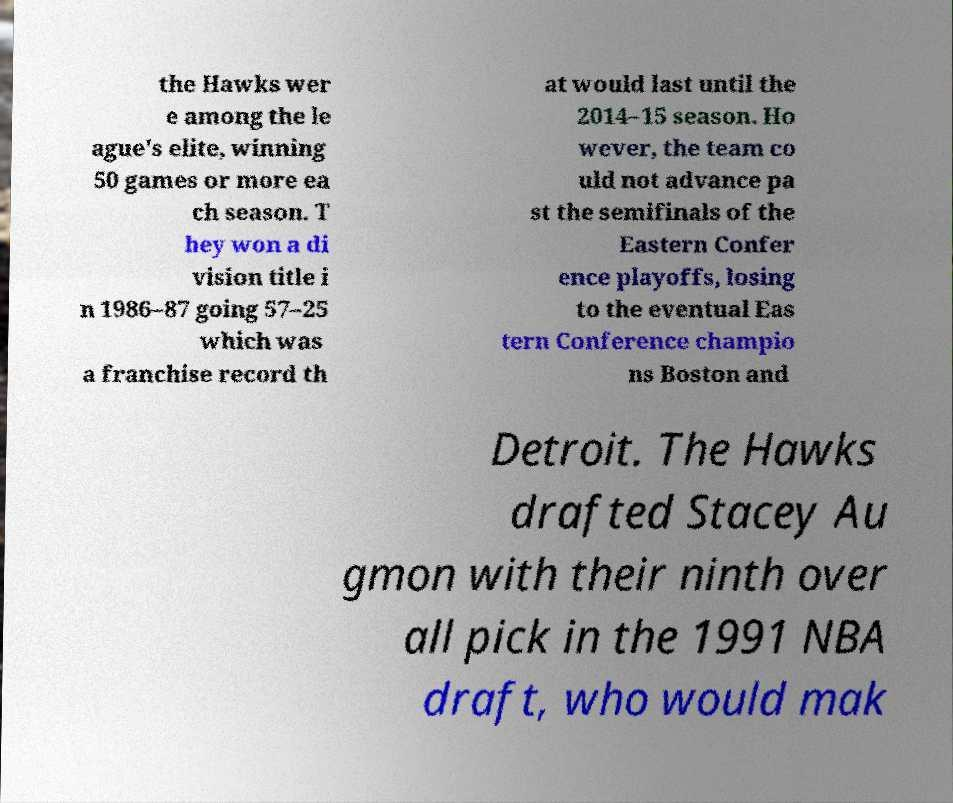Can you read and provide the text displayed in the image?This photo seems to have some interesting text. Can you extract and type it out for me? the Hawks wer e among the le ague's elite, winning 50 games or more ea ch season. T hey won a di vision title i n 1986–87 going 57–25 which was a franchise record th at would last until the 2014–15 season. Ho wever, the team co uld not advance pa st the semifinals of the Eastern Confer ence playoffs, losing to the eventual Eas tern Conference champio ns Boston and Detroit. The Hawks drafted Stacey Au gmon with their ninth over all pick in the 1991 NBA draft, who would mak 